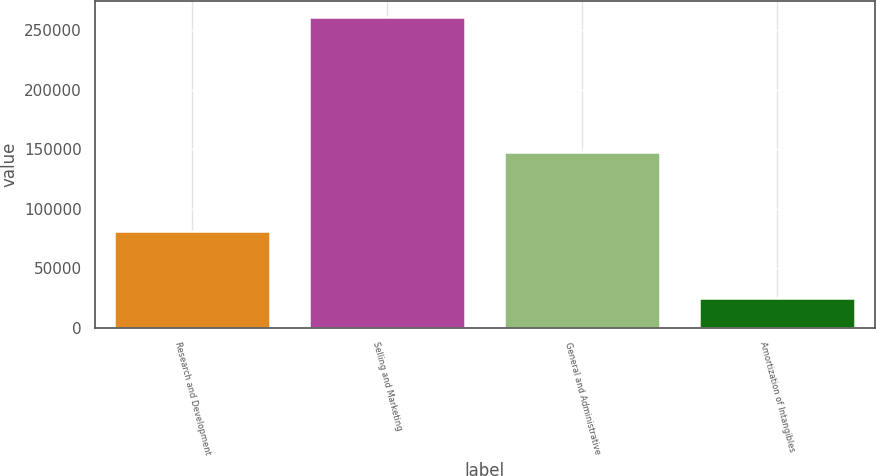Convert chart. <chart><loc_0><loc_0><loc_500><loc_500><bar_chart><fcel>Research and Development<fcel>Selling and Marketing<fcel>General and Administrative<fcel>Amortization of Intangibles<nl><fcel>81421<fcel>261524<fcel>147405<fcel>25227<nl></chart> 